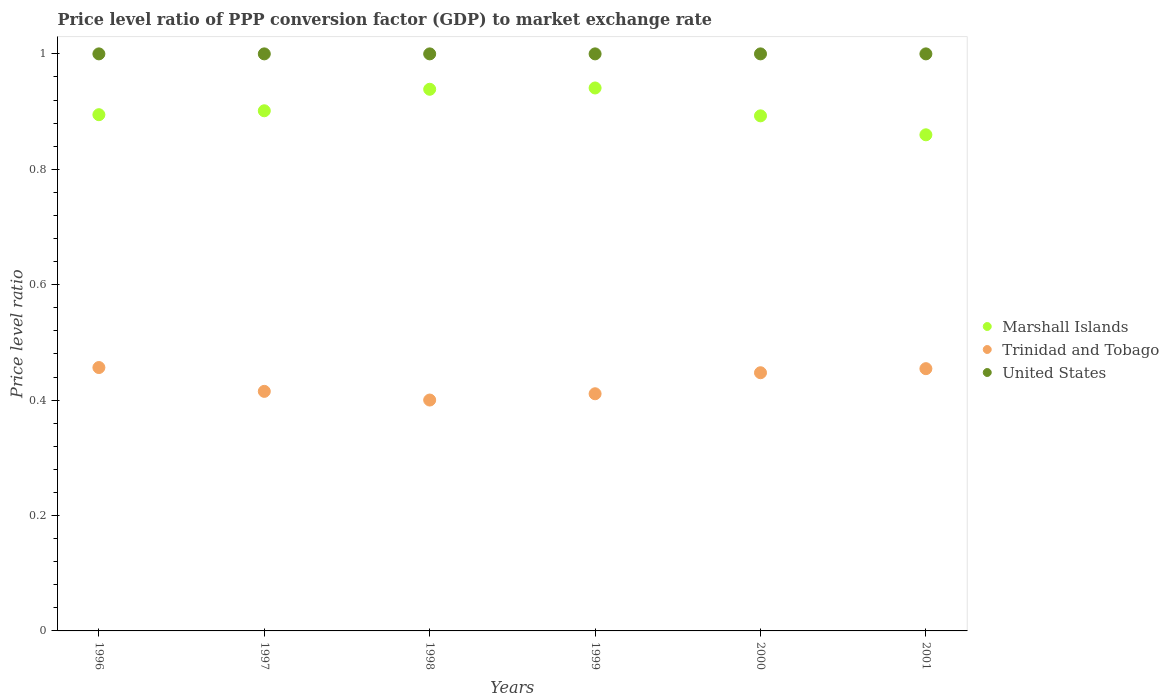How many different coloured dotlines are there?
Give a very brief answer. 3. What is the price level ratio in Trinidad and Tobago in 1998?
Your response must be concise. 0.4. Across all years, what is the maximum price level ratio in United States?
Ensure brevity in your answer.  1. Across all years, what is the minimum price level ratio in Trinidad and Tobago?
Provide a succinct answer. 0.4. In which year was the price level ratio in Marshall Islands maximum?
Your answer should be very brief. 1999. In which year was the price level ratio in Marshall Islands minimum?
Your answer should be very brief. 2001. What is the total price level ratio in Trinidad and Tobago in the graph?
Ensure brevity in your answer.  2.58. What is the difference between the price level ratio in United States in 1996 and that in 2000?
Keep it short and to the point. 0. What is the difference between the price level ratio in Trinidad and Tobago in 1998 and the price level ratio in United States in 1996?
Offer a terse response. -0.6. In the year 2000, what is the difference between the price level ratio in United States and price level ratio in Marshall Islands?
Keep it short and to the point. 0.11. In how many years, is the price level ratio in United States greater than 0.6400000000000001?
Provide a succinct answer. 6. What is the ratio of the price level ratio in Marshall Islands in 1997 to that in 1998?
Your answer should be compact. 0.96. What is the difference between the highest and the second highest price level ratio in Marshall Islands?
Keep it short and to the point. 0. What is the difference between the highest and the lowest price level ratio in Trinidad and Tobago?
Provide a succinct answer. 0.06. In how many years, is the price level ratio in Marshall Islands greater than the average price level ratio in Marshall Islands taken over all years?
Ensure brevity in your answer.  2. Is the sum of the price level ratio in Marshall Islands in 1997 and 2000 greater than the maximum price level ratio in United States across all years?
Give a very brief answer. Yes. Does the price level ratio in Trinidad and Tobago monotonically increase over the years?
Keep it short and to the point. No. Is the price level ratio in Marshall Islands strictly greater than the price level ratio in United States over the years?
Your answer should be very brief. No. Is the price level ratio in Trinidad and Tobago strictly less than the price level ratio in United States over the years?
Provide a short and direct response. Yes. How many dotlines are there?
Your answer should be very brief. 3. How many years are there in the graph?
Provide a short and direct response. 6. What is the difference between two consecutive major ticks on the Y-axis?
Give a very brief answer. 0.2. Does the graph contain grids?
Give a very brief answer. No. How many legend labels are there?
Provide a short and direct response. 3. What is the title of the graph?
Provide a short and direct response. Price level ratio of PPP conversion factor (GDP) to market exchange rate. What is the label or title of the Y-axis?
Your response must be concise. Price level ratio. What is the Price level ratio in Marshall Islands in 1996?
Offer a very short reply. 0.89. What is the Price level ratio of Trinidad and Tobago in 1996?
Your answer should be compact. 0.46. What is the Price level ratio in Marshall Islands in 1997?
Ensure brevity in your answer.  0.9. What is the Price level ratio in Trinidad and Tobago in 1997?
Give a very brief answer. 0.42. What is the Price level ratio of United States in 1997?
Your answer should be compact. 1. What is the Price level ratio of Marshall Islands in 1998?
Provide a succinct answer. 0.94. What is the Price level ratio in Trinidad and Tobago in 1998?
Keep it short and to the point. 0.4. What is the Price level ratio in Marshall Islands in 1999?
Ensure brevity in your answer.  0.94. What is the Price level ratio of Trinidad and Tobago in 1999?
Ensure brevity in your answer.  0.41. What is the Price level ratio of United States in 1999?
Give a very brief answer. 1. What is the Price level ratio of Marshall Islands in 2000?
Make the answer very short. 0.89. What is the Price level ratio of Trinidad and Tobago in 2000?
Give a very brief answer. 0.45. What is the Price level ratio in United States in 2000?
Offer a terse response. 1. What is the Price level ratio in Marshall Islands in 2001?
Offer a terse response. 0.86. What is the Price level ratio in Trinidad and Tobago in 2001?
Make the answer very short. 0.45. Across all years, what is the maximum Price level ratio of Marshall Islands?
Your response must be concise. 0.94. Across all years, what is the maximum Price level ratio in Trinidad and Tobago?
Offer a terse response. 0.46. Across all years, what is the maximum Price level ratio in United States?
Give a very brief answer. 1. Across all years, what is the minimum Price level ratio in Marshall Islands?
Your answer should be compact. 0.86. Across all years, what is the minimum Price level ratio of Trinidad and Tobago?
Offer a very short reply. 0.4. What is the total Price level ratio in Marshall Islands in the graph?
Keep it short and to the point. 5.43. What is the total Price level ratio in Trinidad and Tobago in the graph?
Your answer should be very brief. 2.58. What is the total Price level ratio in United States in the graph?
Offer a very short reply. 6. What is the difference between the Price level ratio of Marshall Islands in 1996 and that in 1997?
Provide a short and direct response. -0.01. What is the difference between the Price level ratio of Trinidad and Tobago in 1996 and that in 1997?
Your answer should be compact. 0.04. What is the difference between the Price level ratio in United States in 1996 and that in 1997?
Offer a terse response. 0. What is the difference between the Price level ratio of Marshall Islands in 1996 and that in 1998?
Your response must be concise. -0.04. What is the difference between the Price level ratio in Trinidad and Tobago in 1996 and that in 1998?
Give a very brief answer. 0.06. What is the difference between the Price level ratio of Marshall Islands in 1996 and that in 1999?
Keep it short and to the point. -0.05. What is the difference between the Price level ratio of Trinidad and Tobago in 1996 and that in 1999?
Your response must be concise. 0.05. What is the difference between the Price level ratio of United States in 1996 and that in 1999?
Ensure brevity in your answer.  0. What is the difference between the Price level ratio of Marshall Islands in 1996 and that in 2000?
Keep it short and to the point. 0. What is the difference between the Price level ratio in Trinidad and Tobago in 1996 and that in 2000?
Offer a very short reply. 0.01. What is the difference between the Price level ratio in United States in 1996 and that in 2000?
Keep it short and to the point. 0. What is the difference between the Price level ratio of Marshall Islands in 1996 and that in 2001?
Offer a terse response. 0.03. What is the difference between the Price level ratio in Trinidad and Tobago in 1996 and that in 2001?
Ensure brevity in your answer.  0. What is the difference between the Price level ratio of Marshall Islands in 1997 and that in 1998?
Give a very brief answer. -0.04. What is the difference between the Price level ratio in Trinidad and Tobago in 1997 and that in 1998?
Your response must be concise. 0.01. What is the difference between the Price level ratio in Marshall Islands in 1997 and that in 1999?
Provide a short and direct response. -0.04. What is the difference between the Price level ratio in Trinidad and Tobago in 1997 and that in 1999?
Your answer should be compact. 0. What is the difference between the Price level ratio in United States in 1997 and that in 1999?
Your answer should be compact. 0. What is the difference between the Price level ratio of Marshall Islands in 1997 and that in 2000?
Give a very brief answer. 0.01. What is the difference between the Price level ratio in Trinidad and Tobago in 1997 and that in 2000?
Make the answer very short. -0.03. What is the difference between the Price level ratio in Marshall Islands in 1997 and that in 2001?
Keep it short and to the point. 0.04. What is the difference between the Price level ratio of Trinidad and Tobago in 1997 and that in 2001?
Keep it short and to the point. -0.04. What is the difference between the Price level ratio in United States in 1997 and that in 2001?
Ensure brevity in your answer.  0. What is the difference between the Price level ratio in Marshall Islands in 1998 and that in 1999?
Give a very brief answer. -0. What is the difference between the Price level ratio in Trinidad and Tobago in 1998 and that in 1999?
Your answer should be very brief. -0.01. What is the difference between the Price level ratio of United States in 1998 and that in 1999?
Offer a very short reply. 0. What is the difference between the Price level ratio of Marshall Islands in 1998 and that in 2000?
Provide a succinct answer. 0.05. What is the difference between the Price level ratio in Trinidad and Tobago in 1998 and that in 2000?
Keep it short and to the point. -0.05. What is the difference between the Price level ratio in United States in 1998 and that in 2000?
Offer a very short reply. 0. What is the difference between the Price level ratio in Marshall Islands in 1998 and that in 2001?
Provide a short and direct response. 0.08. What is the difference between the Price level ratio of Trinidad and Tobago in 1998 and that in 2001?
Your response must be concise. -0.05. What is the difference between the Price level ratio of United States in 1998 and that in 2001?
Provide a short and direct response. 0. What is the difference between the Price level ratio of Marshall Islands in 1999 and that in 2000?
Offer a terse response. 0.05. What is the difference between the Price level ratio of Trinidad and Tobago in 1999 and that in 2000?
Provide a short and direct response. -0.04. What is the difference between the Price level ratio in Marshall Islands in 1999 and that in 2001?
Provide a succinct answer. 0.08. What is the difference between the Price level ratio of Trinidad and Tobago in 1999 and that in 2001?
Offer a terse response. -0.04. What is the difference between the Price level ratio in United States in 1999 and that in 2001?
Make the answer very short. 0. What is the difference between the Price level ratio of Marshall Islands in 2000 and that in 2001?
Offer a terse response. 0.03. What is the difference between the Price level ratio in Trinidad and Tobago in 2000 and that in 2001?
Offer a very short reply. -0.01. What is the difference between the Price level ratio in United States in 2000 and that in 2001?
Ensure brevity in your answer.  0. What is the difference between the Price level ratio in Marshall Islands in 1996 and the Price level ratio in Trinidad and Tobago in 1997?
Give a very brief answer. 0.48. What is the difference between the Price level ratio of Marshall Islands in 1996 and the Price level ratio of United States in 1997?
Your answer should be very brief. -0.11. What is the difference between the Price level ratio of Trinidad and Tobago in 1996 and the Price level ratio of United States in 1997?
Provide a succinct answer. -0.54. What is the difference between the Price level ratio in Marshall Islands in 1996 and the Price level ratio in Trinidad and Tobago in 1998?
Offer a terse response. 0.49. What is the difference between the Price level ratio of Marshall Islands in 1996 and the Price level ratio of United States in 1998?
Your answer should be very brief. -0.11. What is the difference between the Price level ratio in Trinidad and Tobago in 1996 and the Price level ratio in United States in 1998?
Your answer should be compact. -0.54. What is the difference between the Price level ratio of Marshall Islands in 1996 and the Price level ratio of Trinidad and Tobago in 1999?
Your answer should be very brief. 0.48. What is the difference between the Price level ratio of Marshall Islands in 1996 and the Price level ratio of United States in 1999?
Provide a succinct answer. -0.11. What is the difference between the Price level ratio in Trinidad and Tobago in 1996 and the Price level ratio in United States in 1999?
Your answer should be very brief. -0.54. What is the difference between the Price level ratio of Marshall Islands in 1996 and the Price level ratio of Trinidad and Tobago in 2000?
Provide a short and direct response. 0.45. What is the difference between the Price level ratio in Marshall Islands in 1996 and the Price level ratio in United States in 2000?
Provide a short and direct response. -0.11. What is the difference between the Price level ratio of Trinidad and Tobago in 1996 and the Price level ratio of United States in 2000?
Provide a succinct answer. -0.54. What is the difference between the Price level ratio in Marshall Islands in 1996 and the Price level ratio in Trinidad and Tobago in 2001?
Provide a succinct answer. 0.44. What is the difference between the Price level ratio in Marshall Islands in 1996 and the Price level ratio in United States in 2001?
Your answer should be very brief. -0.11. What is the difference between the Price level ratio of Trinidad and Tobago in 1996 and the Price level ratio of United States in 2001?
Your answer should be very brief. -0.54. What is the difference between the Price level ratio of Marshall Islands in 1997 and the Price level ratio of Trinidad and Tobago in 1998?
Give a very brief answer. 0.5. What is the difference between the Price level ratio in Marshall Islands in 1997 and the Price level ratio in United States in 1998?
Keep it short and to the point. -0.1. What is the difference between the Price level ratio in Trinidad and Tobago in 1997 and the Price level ratio in United States in 1998?
Ensure brevity in your answer.  -0.58. What is the difference between the Price level ratio of Marshall Islands in 1997 and the Price level ratio of Trinidad and Tobago in 1999?
Provide a short and direct response. 0.49. What is the difference between the Price level ratio of Marshall Islands in 1997 and the Price level ratio of United States in 1999?
Make the answer very short. -0.1. What is the difference between the Price level ratio of Trinidad and Tobago in 1997 and the Price level ratio of United States in 1999?
Your answer should be compact. -0.58. What is the difference between the Price level ratio of Marshall Islands in 1997 and the Price level ratio of Trinidad and Tobago in 2000?
Make the answer very short. 0.45. What is the difference between the Price level ratio in Marshall Islands in 1997 and the Price level ratio in United States in 2000?
Your response must be concise. -0.1. What is the difference between the Price level ratio of Trinidad and Tobago in 1997 and the Price level ratio of United States in 2000?
Make the answer very short. -0.58. What is the difference between the Price level ratio of Marshall Islands in 1997 and the Price level ratio of Trinidad and Tobago in 2001?
Provide a short and direct response. 0.45. What is the difference between the Price level ratio in Marshall Islands in 1997 and the Price level ratio in United States in 2001?
Keep it short and to the point. -0.1. What is the difference between the Price level ratio of Trinidad and Tobago in 1997 and the Price level ratio of United States in 2001?
Make the answer very short. -0.58. What is the difference between the Price level ratio in Marshall Islands in 1998 and the Price level ratio in Trinidad and Tobago in 1999?
Your response must be concise. 0.53. What is the difference between the Price level ratio of Marshall Islands in 1998 and the Price level ratio of United States in 1999?
Ensure brevity in your answer.  -0.06. What is the difference between the Price level ratio of Trinidad and Tobago in 1998 and the Price level ratio of United States in 1999?
Give a very brief answer. -0.6. What is the difference between the Price level ratio in Marshall Islands in 1998 and the Price level ratio in Trinidad and Tobago in 2000?
Give a very brief answer. 0.49. What is the difference between the Price level ratio of Marshall Islands in 1998 and the Price level ratio of United States in 2000?
Offer a very short reply. -0.06. What is the difference between the Price level ratio in Trinidad and Tobago in 1998 and the Price level ratio in United States in 2000?
Offer a terse response. -0.6. What is the difference between the Price level ratio of Marshall Islands in 1998 and the Price level ratio of Trinidad and Tobago in 2001?
Provide a short and direct response. 0.48. What is the difference between the Price level ratio in Marshall Islands in 1998 and the Price level ratio in United States in 2001?
Give a very brief answer. -0.06. What is the difference between the Price level ratio in Trinidad and Tobago in 1998 and the Price level ratio in United States in 2001?
Offer a very short reply. -0.6. What is the difference between the Price level ratio in Marshall Islands in 1999 and the Price level ratio in Trinidad and Tobago in 2000?
Make the answer very short. 0.49. What is the difference between the Price level ratio in Marshall Islands in 1999 and the Price level ratio in United States in 2000?
Provide a succinct answer. -0.06. What is the difference between the Price level ratio in Trinidad and Tobago in 1999 and the Price level ratio in United States in 2000?
Make the answer very short. -0.59. What is the difference between the Price level ratio in Marshall Islands in 1999 and the Price level ratio in Trinidad and Tobago in 2001?
Make the answer very short. 0.49. What is the difference between the Price level ratio of Marshall Islands in 1999 and the Price level ratio of United States in 2001?
Give a very brief answer. -0.06. What is the difference between the Price level ratio of Trinidad and Tobago in 1999 and the Price level ratio of United States in 2001?
Offer a terse response. -0.59. What is the difference between the Price level ratio in Marshall Islands in 2000 and the Price level ratio in Trinidad and Tobago in 2001?
Provide a succinct answer. 0.44. What is the difference between the Price level ratio in Marshall Islands in 2000 and the Price level ratio in United States in 2001?
Give a very brief answer. -0.11. What is the difference between the Price level ratio of Trinidad and Tobago in 2000 and the Price level ratio of United States in 2001?
Your answer should be compact. -0.55. What is the average Price level ratio of Marshall Islands per year?
Give a very brief answer. 0.9. What is the average Price level ratio in Trinidad and Tobago per year?
Ensure brevity in your answer.  0.43. What is the average Price level ratio in United States per year?
Your answer should be very brief. 1. In the year 1996, what is the difference between the Price level ratio in Marshall Islands and Price level ratio in Trinidad and Tobago?
Your answer should be very brief. 0.44. In the year 1996, what is the difference between the Price level ratio of Marshall Islands and Price level ratio of United States?
Ensure brevity in your answer.  -0.11. In the year 1996, what is the difference between the Price level ratio of Trinidad and Tobago and Price level ratio of United States?
Ensure brevity in your answer.  -0.54. In the year 1997, what is the difference between the Price level ratio of Marshall Islands and Price level ratio of Trinidad and Tobago?
Your answer should be compact. 0.49. In the year 1997, what is the difference between the Price level ratio in Marshall Islands and Price level ratio in United States?
Keep it short and to the point. -0.1. In the year 1997, what is the difference between the Price level ratio of Trinidad and Tobago and Price level ratio of United States?
Make the answer very short. -0.58. In the year 1998, what is the difference between the Price level ratio of Marshall Islands and Price level ratio of Trinidad and Tobago?
Provide a succinct answer. 0.54. In the year 1998, what is the difference between the Price level ratio of Marshall Islands and Price level ratio of United States?
Your answer should be compact. -0.06. In the year 1998, what is the difference between the Price level ratio of Trinidad and Tobago and Price level ratio of United States?
Your answer should be very brief. -0.6. In the year 1999, what is the difference between the Price level ratio of Marshall Islands and Price level ratio of Trinidad and Tobago?
Provide a succinct answer. 0.53. In the year 1999, what is the difference between the Price level ratio of Marshall Islands and Price level ratio of United States?
Keep it short and to the point. -0.06. In the year 1999, what is the difference between the Price level ratio in Trinidad and Tobago and Price level ratio in United States?
Your answer should be very brief. -0.59. In the year 2000, what is the difference between the Price level ratio of Marshall Islands and Price level ratio of Trinidad and Tobago?
Give a very brief answer. 0.45. In the year 2000, what is the difference between the Price level ratio in Marshall Islands and Price level ratio in United States?
Offer a very short reply. -0.11. In the year 2000, what is the difference between the Price level ratio of Trinidad and Tobago and Price level ratio of United States?
Provide a short and direct response. -0.55. In the year 2001, what is the difference between the Price level ratio of Marshall Islands and Price level ratio of Trinidad and Tobago?
Make the answer very short. 0.41. In the year 2001, what is the difference between the Price level ratio in Marshall Islands and Price level ratio in United States?
Your answer should be compact. -0.14. In the year 2001, what is the difference between the Price level ratio in Trinidad and Tobago and Price level ratio in United States?
Offer a terse response. -0.55. What is the ratio of the Price level ratio of Trinidad and Tobago in 1996 to that in 1997?
Provide a succinct answer. 1.1. What is the ratio of the Price level ratio of Marshall Islands in 1996 to that in 1998?
Provide a succinct answer. 0.95. What is the ratio of the Price level ratio in Trinidad and Tobago in 1996 to that in 1998?
Your answer should be compact. 1.14. What is the ratio of the Price level ratio in United States in 1996 to that in 1998?
Provide a short and direct response. 1. What is the ratio of the Price level ratio of Marshall Islands in 1996 to that in 1999?
Keep it short and to the point. 0.95. What is the ratio of the Price level ratio of Trinidad and Tobago in 1996 to that in 1999?
Your answer should be compact. 1.11. What is the ratio of the Price level ratio of Trinidad and Tobago in 1996 to that in 2000?
Offer a terse response. 1.02. What is the ratio of the Price level ratio of Marshall Islands in 1996 to that in 2001?
Make the answer very short. 1.04. What is the ratio of the Price level ratio in United States in 1996 to that in 2001?
Provide a short and direct response. 1. What is the ratio of the Price level ratio in Marshall Islands in 1997 to that in 1998?
Provide a succinct answer. 0.96. What is the ratio of the Price level ratio in Trinidad and Tobago in 1997 to that in 1998?
Make the answer very short. 1.04. What is the ratio of the Price level ratio of United States in 1997 to that in 1998?
Ensure brevity in your answer.  1. What is the ratio of the Price level ratio of Marshall Islands in 1997 to that in 1999?
Keep it short and to the point. 0.96. What is the ratio of the Price level ratio in Marshall Islands in 1997 to that in 2000?
Offer a terse response. 1.01. What is the ratio of the Price level ratio in Trinidad and Tobago in 1997 to that in 2000?
Keep it short and to the point. 0.93. What is the ratio of the Price level ratio in Marshall Islands in 1997 to that in 2001?
Your response must be concise. 1.05. What is the ratio of the Price level ratio in Trinidad and Tobago in 1997 to that in 2001?
Give a very brief answer. 0.91. What is the ratio of the Price level ratio of United States in 1997 to that in 2001?
Provide a succinct answer. 1. What is the ratio of the Price level ratio in Marshall Islands in 1998 to that in 1999?
Your answer should be very brief. 1. What is the ratio of the Price level ratio in Trinidad and Tobago in 1998 to that in 1999?
Offer a terse response. 0.97. What is the ratio of the Price level ratio in Marshall Islands in 1998 to that in 2000?
Make the answer very short. 1.05. What is the ratio of the Price level ratio in Trinidad and Tobago in 1998 to that in 2000?
Your response must be concise. 0.89. What is the ratio of the Price level ratio in United States in 1998 to that in 2000?
Ensure brevity in your answer.  1. What is the ratio of the Price level ratio of Marshall Islands in 1998 to that in 2001?
Make the answer very short. 1.09. What is the ratio of the Price level ratio in Trinidad and Tobago in 1998 to that in 2001?
Keep it short and to the point. 0.88. What is the ratio of the Price level ratio of United States in 1998 to that in 2001?
Ensure brevity in your answer.  1. What is the ratio of the Price level ratio in Marshall Islands in 1999 to that in 2000?
Ensure brevity in your answer.  1.05. What is the ratio of the Price level ratio of Trinidad and Tobago in 1999 to that in 2000?
Give a very brief answer. 0.92. What is the ratio of the Price level ratio of Marshall Islands in 1999 to that in 2001?
Make the answer very short. 1.09. What is the ratio of the Price level ratio of Trinidad and Tobago in 1999 to that in 2001?
Provide a short and direct response. 0.9. What is the ratio of the Price level ratio of United States in 1999 to that in 2001?
Ensure brevity in your answer.  1. What is the ratio of the Price level ratio in Marshall Islands in 2000 to that in 2001?
Your response must be concise. 1.04. What is the ratio of the Price level ratio in Trinidad and Tobago in 2000 to that in 2001?
Your response must be concise. 0.98. What is the difference between the highest and the second highest Price level ratio in Marshall Islands?
Offer a very short reply. 0. What is the difference between the highest and the second highest Price level ratio of Trinidad and Tobago?
Your answer should be very brief. 0. What is the difference between the highest and the second highest Price level ratio of United States?
Make the answer very short. 0. What is the difference between the highest and the lowest Price level ratio of Marshall Islands?
Your response must be concise. 0.08. What is the difference between the highest and the lowest Price level ratio in Trinidad and Tobago?
Your answer should be very brief. 0.06. What is the difference between the highest and the lowest Price level ratio of United States?
Provide a short and direct response. 0. 